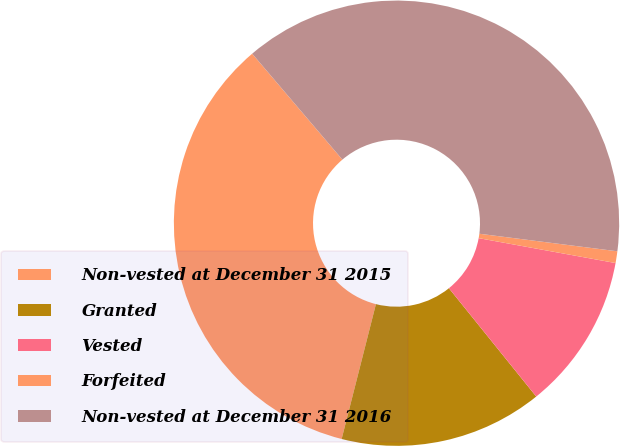Convert chart. <chart><loc_0><loc_0><loc_500><loc_500><pie_chart><fcel>Non-vested at December 31 2015<fcel>Granted<fcel>Vested<fcel>Forfeited<fcel>Non-vested at December 31 2016<nl><fcel>34.81%<fcel>14.76%<fcel>11.34%<fcel>0.85%<fcel>38.24%<nl></chart> 